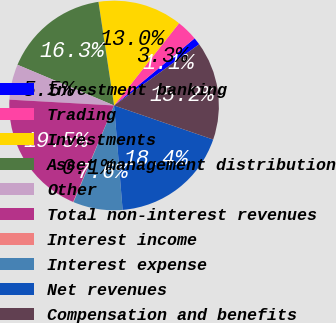<chart> <loc_0><loc_0><loc_500><loc_500><pie_chart><fcel>Investment banking<fcel>Trading<fcel>Investments<fcel>Asset management distribution<fcel>Other<fcel>Total non-interest revenues<fcel>Interest income<fcel>Interest expense<fcel>Net revenues<fcel>Compensation and benefits<nl><fcel>1.14%<fcel>3.3%<fcel>13.03%<fcel>16.27%<fcel>5.46%<fcel>19.51%<fcel>0.06%<fcel>7.62%<fcel>18.43%<fcel>15.19%<nl></chart> 